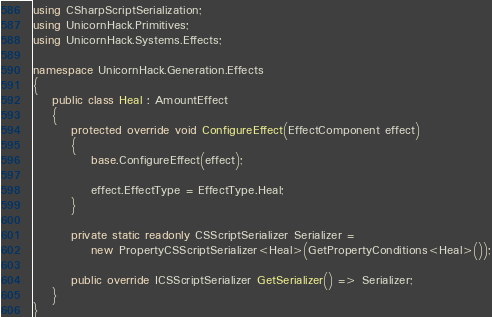<code> <loc_0><loc_0><loc_500><loc_500><_C#_>using CSharpScriptSerialization;
using UnicornHack.Primitives;
using UnicornHack.Systems.Effects;

namespace UnicornHack.Generation.Effects
{
    public class Heal : AmountEffect
    {
        protected override void ConfigureEffect(EffectComponent effect)
        {
            base.ConfigureEffect(effect);

            effect.EffectType = EffectType.Heal;
        }

        private static readonly CSScriptSerializer Serializer =
            new PropertyCSScriptSerializer<Heal>(GetPropertyConditions<Heal>());

        public override ICSScriptSerializer GetSerializer() => Serializer;
    }
}
</code> 